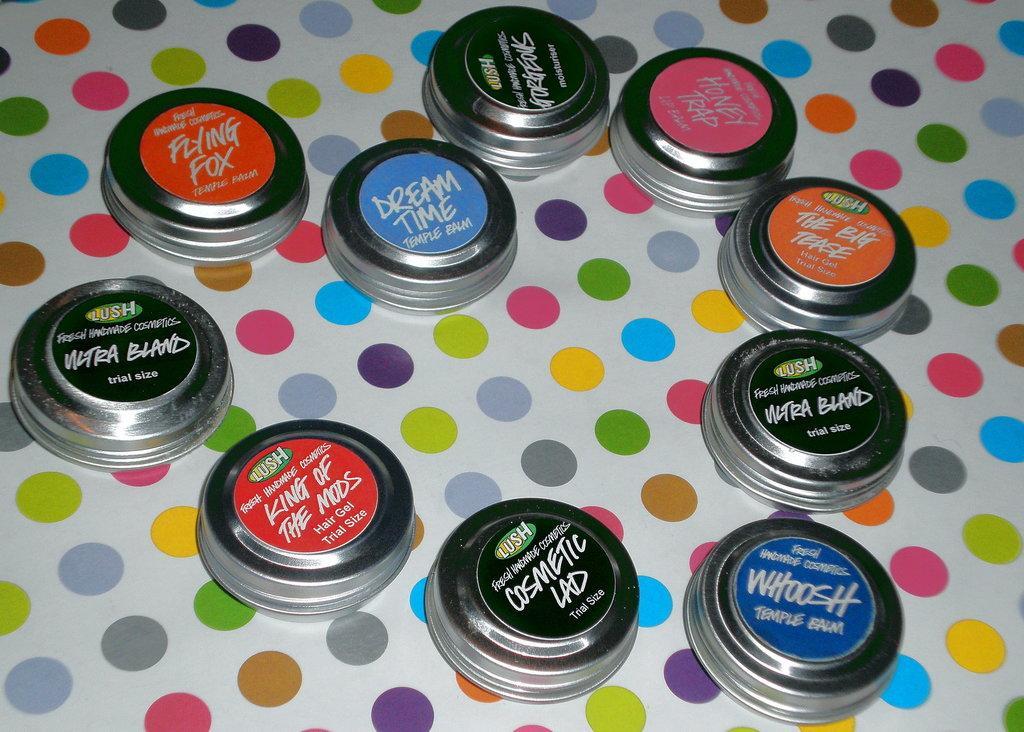Could you give a brief overview of what you see in this image? In this picture I can see kids on an object. 